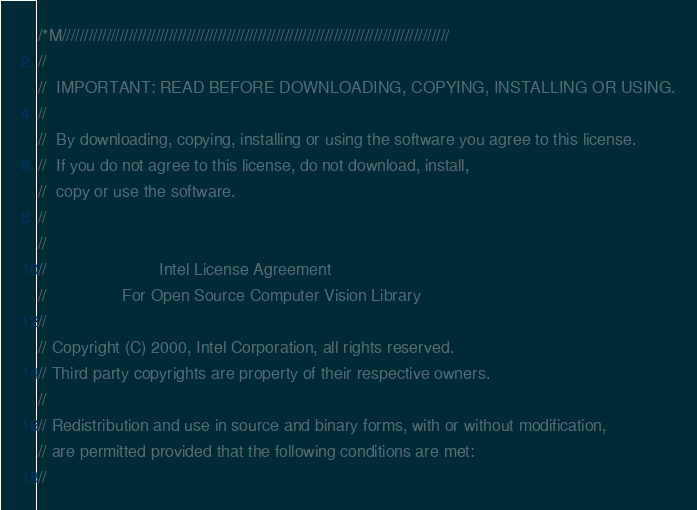Convert code to text. <code><loc_0><loc_0><loc_500><loc_500><_C++_>/*M///////////////////////////////////////////////////////////////////////////////////////
//
//  IMPORTANT: READ BEFORE DOWNLOADING, COPYING, INSTALLING OR USING.
//
//  By downloading, copying, installing or using the software you agree to this license.
//  If you do not agree to this license, do not download, install,
//  copy or use the software.
//
//
//                        Intel License Agreement
//                For Open Source Computer Vision Library
//
// Copyright (C) 2000, Intel Corporation, all rights reserved.
// Third party copyrights are property of their respective owners.
//
// Redistribution and use in source and binary forms, with or without modification,
// are permitted provided that the following conditions are met:
//</code> 